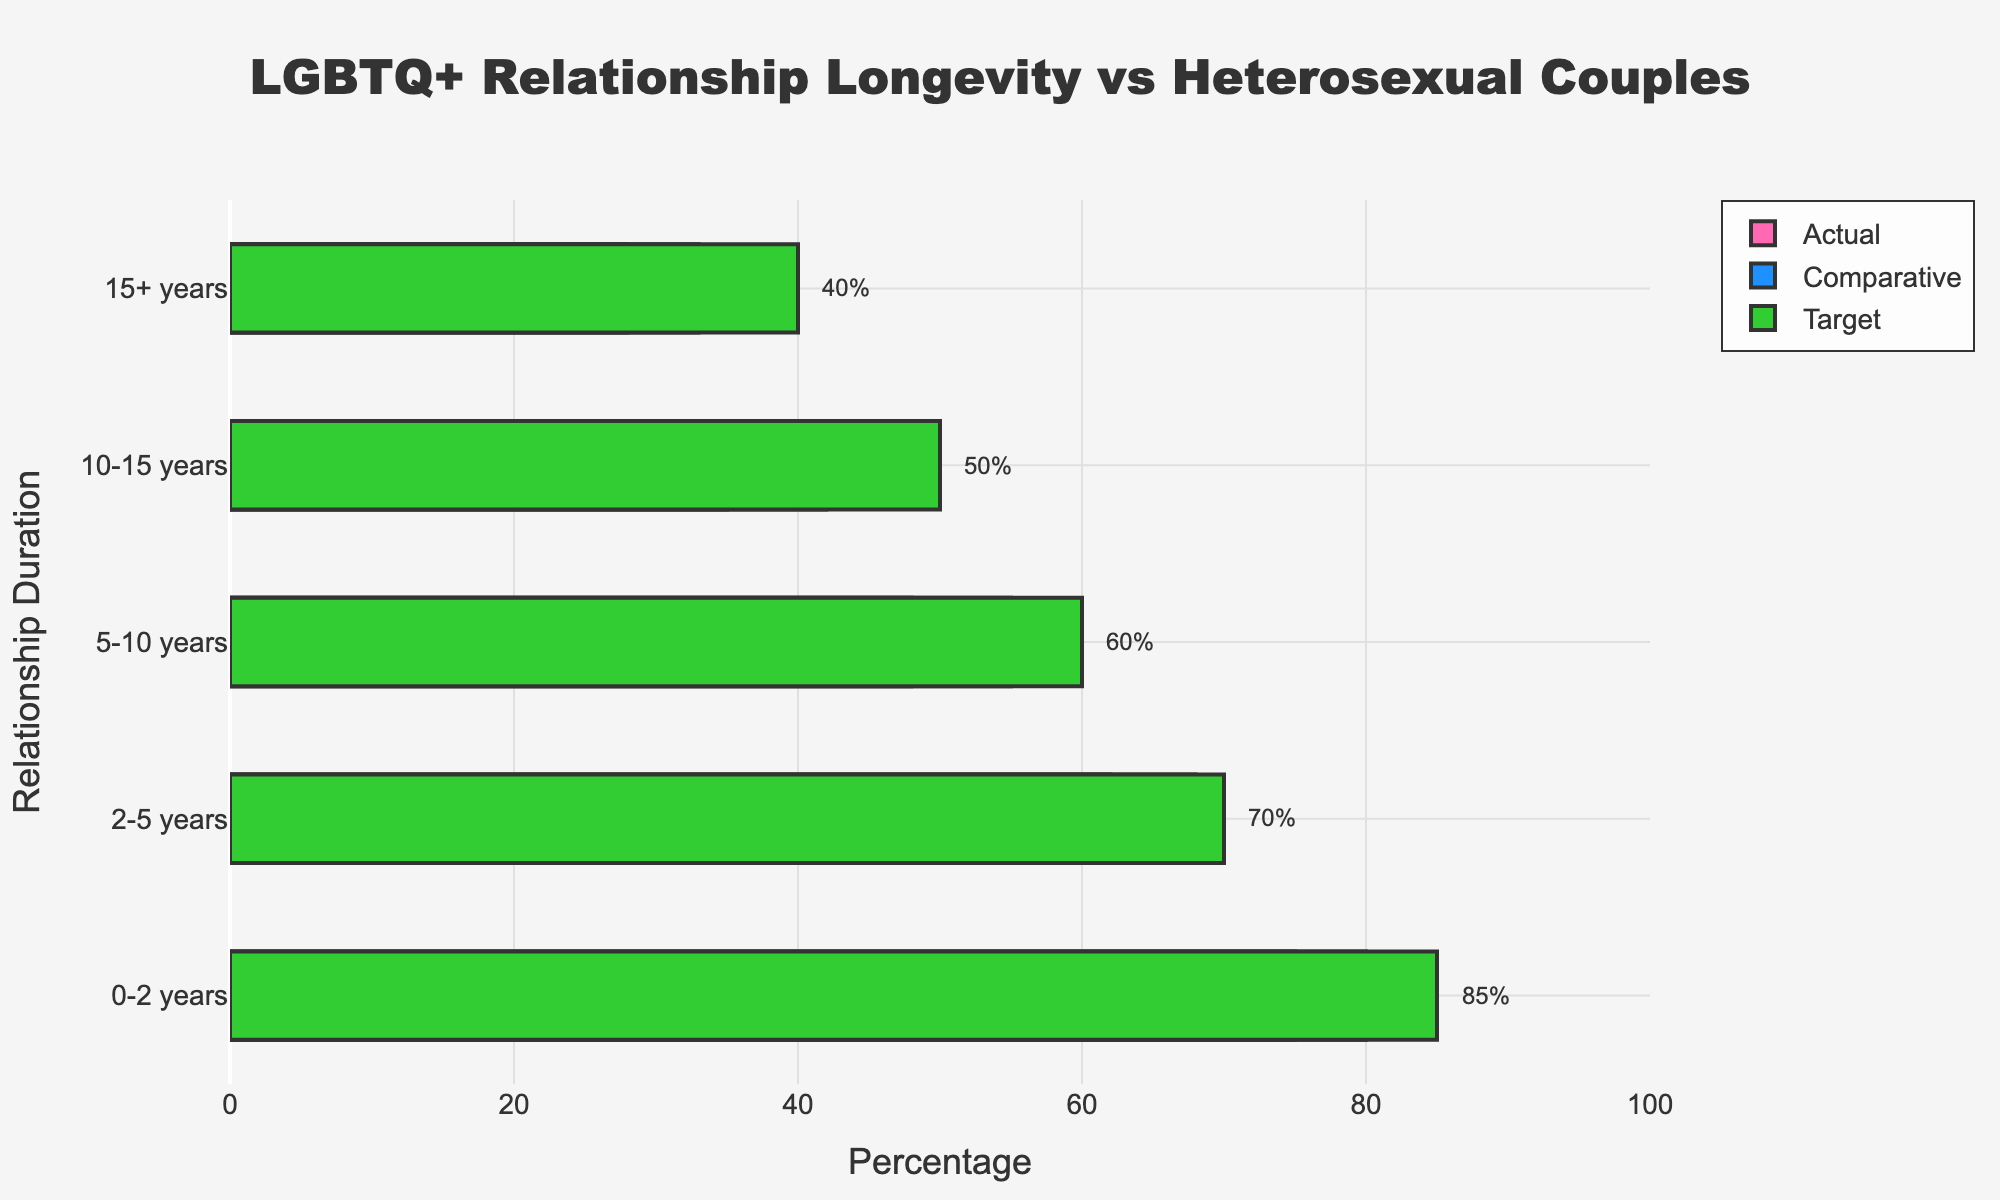How is the relationship duration category labeled on the y-axis? The y-axis of the figure represents relationship duration categories, such as "0-2 years," "2-5 years," "5-10 years," "10-15 years," and "15+ years." These labels help to divide the relationship data into distinct time intervals.
Answer: "0-2 years," "2-5 years," "5-10 years," "10-15 years," "15+ years" Which relationship duration category has the largest difference between the actual percentage of LGBTQ+ relationships and the target percentage? To identify the largest difference, we need to calculate the difference for each category. For "0-2 years" it's 85 - 75 = 10, for "2-5 years" it's 70 - 62 = 8, for "5-10 years" it's 60 - 48 = 12, for "10-15 years" it's 50 - 35 = 15, and for "15+ years" it's 40 - 28 = 12. Thus, the largest difference is in the "10-15 years" category.
Answer: 10-15 years How does the percentage of comparative heterosexual relationships in the 5-10 years category compare to the actual percentage of LGBTQ+ relationships in the same category? The comparative percentage for heterosexual relationships in the "5-10 years" category is 55%, while the actual percentage for LGBTQ+ relationships is 48%. Comparing these percentages, 48% is less than 55%.
Answer: Less than What pattern do you observe in the actual percentage of LGBTQ+ relationships as the relationship duration increases? Observing the actual percentages, they are 75% for "0-2 years," 62% for "2-5 years," 48% for "5-10 years," 35% for "10-15 years," and 28% for "15+ years." The pattern shows a clear decrease in the percentage of LGBTQ+ relationships as the relationship duration increases.
Answer: Decrease Which relationship duration category has the smallest difference between actual and comparative percentages of LGBTQ+ and heterosexual relationships? To find the smallest difference, calculate the difference for each category: "0-2 years" is 80 - 75 = 5, "2-5 years" is 68 - 62 = 6, "5-10 years" is 55 - 48 = 7, "10-15 years" is 42 - 35 = 7, "15+ years" is 33 - 28 = 5. The smallest differences are in the "0-2 years" and "15+ years" categories with a difference of 5.
Answer: 0-2 years, 15+ years What is the target percentage for heterosexual relationships in the 2-5 years category? On the bar chart, the target percentage for the "2-5 years" category is displayed as a single bar labeled "70%," and there is also an annotation beside the bar.
Answer: 70% Compare the actual ending percentages between the "10-15 years" category and the "15+ years" category for LGBTQ+ relationships. Which one has a higher percentage? The actual percentage for the "10-15 years" category is 35%, while the "15+ years" category is at 28%. Comparing these percentages, 35% is higher than 28%.
Answer: 10-15 years In which category is the difference between the actual LGBTQ+ percentage and the comparative heterosexual percentage greater than 10%? Calculate the differences: "0-2 years" is 80 - 75 = 5, "2-5 years" is 68 - 62 = 6, "5-10 years" is 55 - 48 = 7, "10-15 years" is 42 - 35 = 7, "15+ years" is 33 - 28 = 5. None of the categories have a difference greater than 10%.
Answer: None 